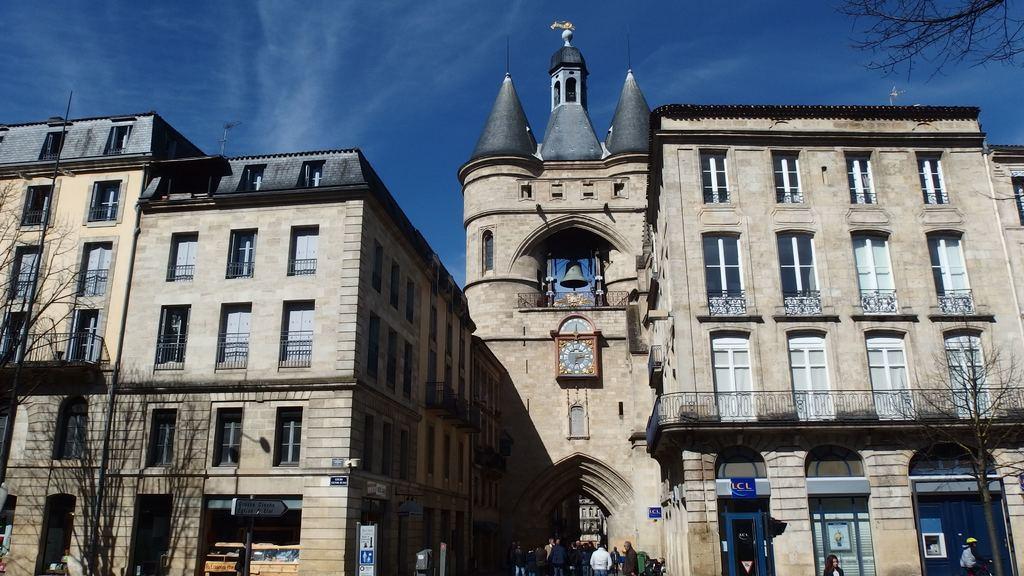Describe this image in one or two sentences. This image is taken outdoors. At the top of the image there is the sky with clouds. In the middle of the image there are two buildings with walls, windows, roofs, grills, railings, balconies and pillars. There is a bell and there is a clock. There are a few trees. At the bottom of the image a few people are walking on the floor. There are a few doors. 